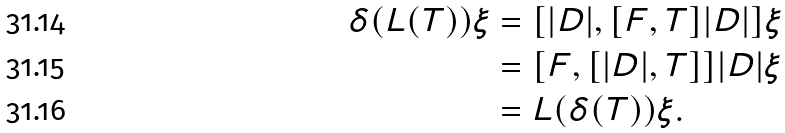<formula> <loc_0><loc_0><loc_500><loc_500>\delta ( L ( T ) ) \xi & = [ | D | , [ F , T ] | D | ] \xi \\ & = [ F , [ | D | , T ] ] | D | \xi \\ & = L ( \delta ( T ) ) \xi .</formula> 